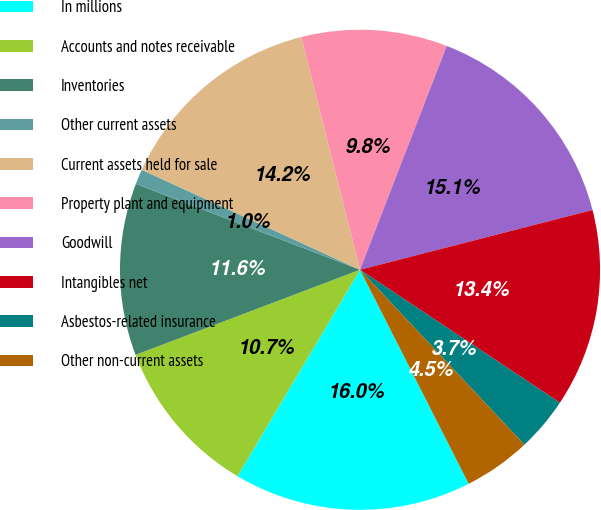Convert chart to OTSL. <chart><loc_0><loc_0><loc_500><loc_500><pie_chart><fcel>In millions<fcel>Accounts and notes receivable<fcel>Inventories<fcel>Other current assets<fcel>Current assets held for sale<fcel>Property plant and equipment<fcel>Goodwill<fcel>Intangibles net<fcel>Asbestos-related insurance<fcel>Other non-current assets<nl><fcel>16.0%<fcel>10.71%<fcel>11.59%<fcel>1.01%<fcel>14.23%<fcel>9.82%<fcel>15.11%<fcel>13.35%<fcel>3.65%<fcel>4.53%<nl></chart> 